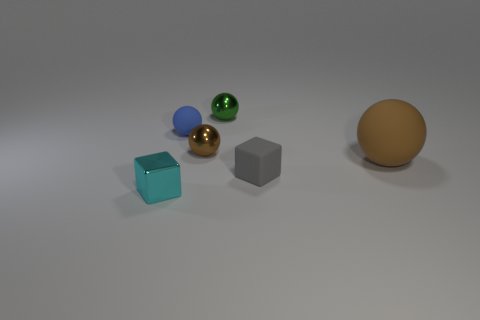Subtract all small brown metallic balls. How many balls are left? 3 Subtract all blue balls. How many balls are left? 3 Subtract all cyan cylinders. How many brown balls are left? 2 Add 4 small purple blocks. How many objects exist? 10 Subtract 2 spheres. How many spheres are left? 2 Subtract all green spheres. Subtract all green cylinders. How many spheres are left? 3 Subtract all balls. How many objects are left? 2 Add 4 green metallic things. How many green metallic things are left? 5 Add 5 big red matte cylinders. How many big red matte cylinders exist? 5 Subtract 0 red blocks. How many objects are left? 6 